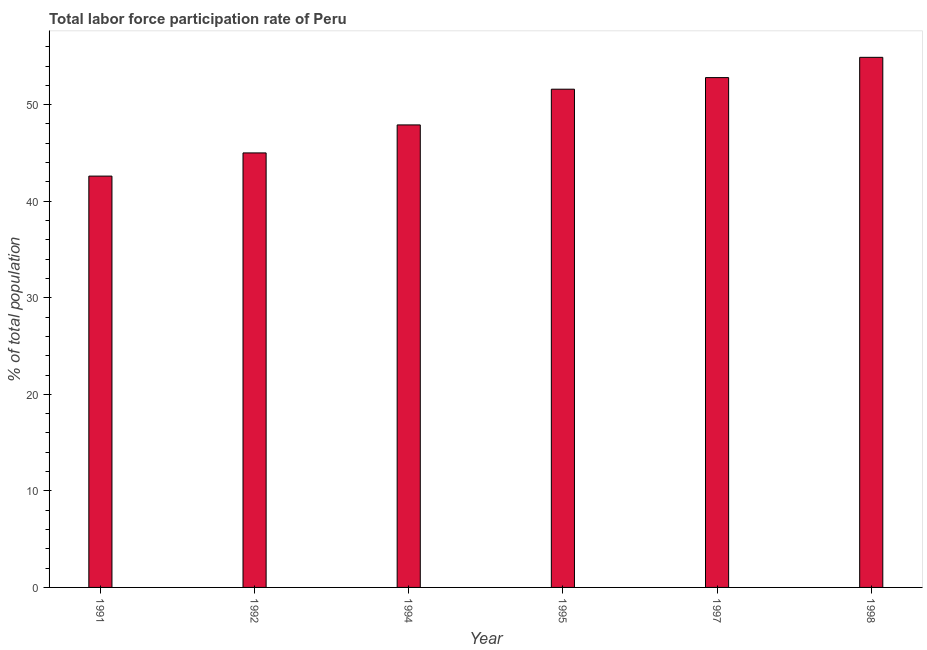Does the graph contain any zero values?
Provide a short and direct response. No. What is the title of the graph?
Provide a succinct answer. Total labor force participation rate of Peru. What is the label or title of the X-axis?
Offer a very short reply. Year. What is the label or title of the Y-axis?
Ensure brevity in your answer.  % of total population. What is the total labor force participation rate in 1991?
Keep it short and to the point. 42.6. Across all years, what is the maximum total labor force participation rate?
Give a very brief answer. 54.9. Across all years, what is the minimum total labor force participation rate?
Keep it short and to the point. 42.6. In which year was the total labor force participation rate maximum?
Your answer should be compact. 1998. In which year was the total labor force participation rate minimum?
Provide a succinct answer. 1991. What is the sum of the total labor force participation rate?
Provide a short and direct response. 294.8. What is the difference between the total labor force participation rate in 1994 and 1998?
Keep it short and to the point. -7. What is the average total labor force participation rate per year?
Ensure brevity in your answer.  49.13. What is the median total labor force participation rate?
Offer a very short reply. 49.75. In how many years, is the total labor force participation rate greater than 26 %?
Keep it short and to the point. 6. Is the total labor force participation rate in 1994 less than that in 1998?
Your answer should be very brief. Yes. Is the difference between the total labor force participation rate in 1992 and 1998 greater than the difference between any two years?
Provide a succinct answer. No. Is the sum of the total labor force participation rate in 1992 and 1997 greater than the maximum total labor force participation rate across all years?
Offer a terse response. Yes. What is the % of total population of 1991?
Your answer should be compact. 42.6. What is the % of total population of 1992?
Make the answer very short. 45. What is the % of total population of 1994?
Your response must be concise. 47.9. What is the % of total population of 1995?
Your answer should be very brief. 51.6. What is the % of total population of 1997?
Ensure brevity in your answer.  52.8. What is the % of total population of 1998?
Provide a succinct answer. 54.9. What is the difference between the % of total population in 1991 and 1997?
Offer a terse response. -10.2. What is the difference between the % of total population in 1991 and 1998?
Offer a terse response. -12.3. What is the difference between the % of total population in 1992 and 1994?
Your answer should be compact. -2.9. What is the difference between the % of total population in 1992 and 1995?
Give a very brief answer. -6.6. What is the difference between the % of total population in 1992 and 1998?
Ensure brevity in your answer.  -9.9. What is the difference between the % of total population in 1994 and 1997?
Your answer should be compact. -4.9. What is the difference between the % of total population in 1994 and 1998?
Your answer should be compact. -7. What is the difference between the % of total population in 1995 and 1997?
Your answer should be very brief. -1.2. What is the difference between the % of total population in 1995 and 1998?
Offer a very short reply. -3.3. What is the difference between the % of total population in 1997 and 1998?
Provide a succinct answer. -2.1. What is the ratio of the % of total population in 1991 to that in 1992?
Your answer should be very brief. 0.95. What is the ratio of the % of total population in 1991 to that in 1994?
Offer a terse response. 0.89. What is the ratio of the % of total population in 1991 to that in 1995?
Provide a short and direct response. 0.83. What is the ratio of the % of total population in 1991 to that in 1997?
Your answer should be very brief. 0.81. What is the ratio of the % of total population in 1991 to that in 1998?
Provide a succinct answer. 0.78. What is the ratio of the % of total population in 1992 to that in 1994?
Provide a short and direct response. 0.94. What is the ratio of the % of total population in 1992 to that in 1995?
Make the answer very short. 0.87. What is the ratio of the % of total population in 1992 to that in 1997?
Your answer should be compact. 0.85. What is the ratio of the % of total population in 1992 to that in 1998?
Offer a very short reply. 0.82. What is the ratio of the % of total population in 1994 to that in 1995?
Offer a very short reply. 0.93. What is the ratio of the % of total population in 1994 to that in 1997?
Keep it short and to the point. 0.91. What is the ratio of the % of total population in 1994 to that in 1998?
Ensure brevity in your answer.  0.87. What is the ratio of the % of total population in 1997 to that in 1998?
Ensure brevity in your answer.  0.96. 